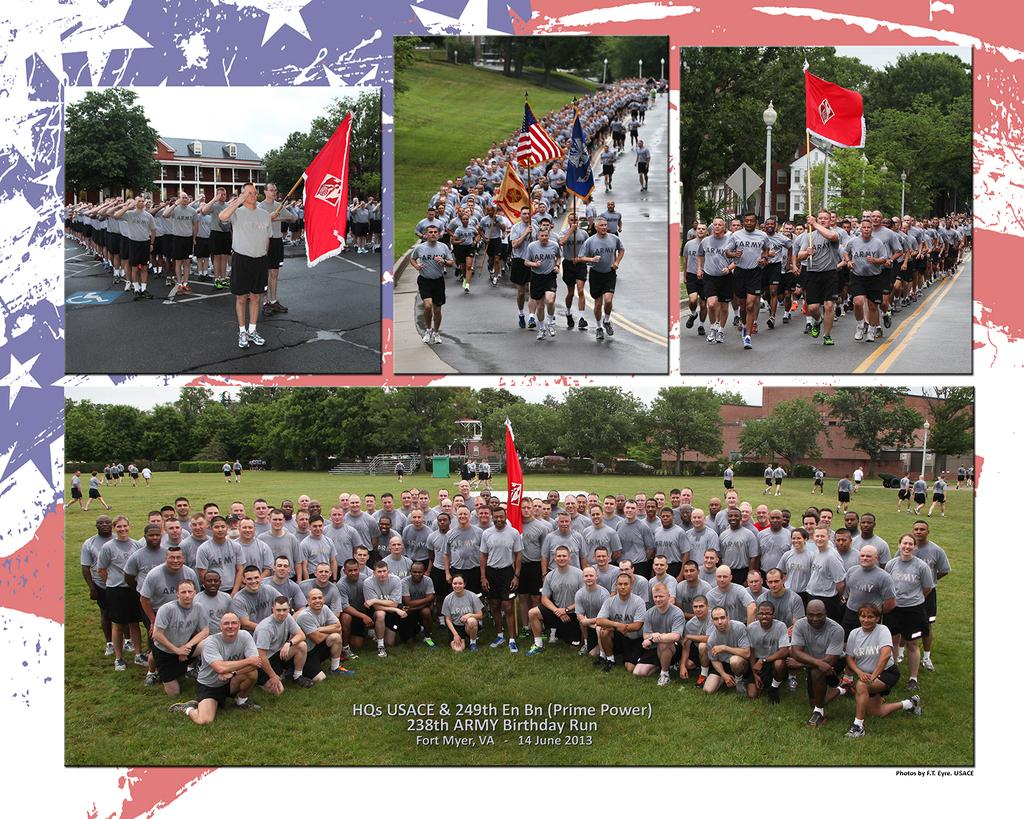What type of artwork is the image? The image is a collage. What types of elements can be seen in the collage? There are people, flags, trees, buildings, and grass visible in the collage. What type of week is depicted in the collage? There is no depiction of a week in the collage; it features various elements such as people, flags, trees, buildings, and grass. What material is the lead used for in the collage? There is no lead present in the collage; it features various elements such as people, flags, trees, buildings, and grass. 